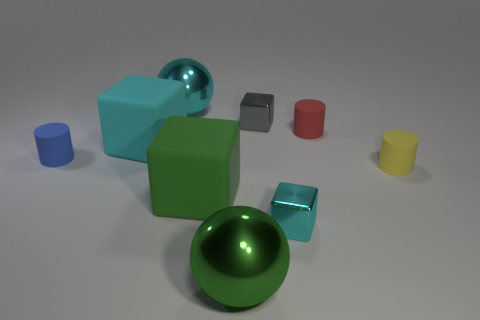Are there any tiny gray cubes made of the same material as the big cyan cube?
Make the answer very short. No. What number of rubber cylinders are there?
Provide a short and direct response. 3. Do the big cyan sphere and the cyan block that is right of the green shiny ball have the same material?
Keep it short and to the point. Yes. What size is the cyan metallic block?
Make the answer very short. Small. Do the green matte object and the cyan object that is right of the big green rubber block have the same shape?
Give a very brief answer. Yes. What is the color of the large thing that is the same material as the big green cube?
Your answer should be compact. Cyan. How big is the sphere that is in front of the small blue matte thing?
Offer a very short reply. Large. Are there fewer tiny cyan blocks that are behind the small blue object than large yellow metal objects?
Offer a very short reply. No. Are there fewer tiny red matte cylinders than large cyan things?
Keep it short and to the point. Yes. There is a small rubber cylinder that is on the left side of the tiny shiny cube in front of the yellow thing; what color is it?
Your response must be concise. Blue. 